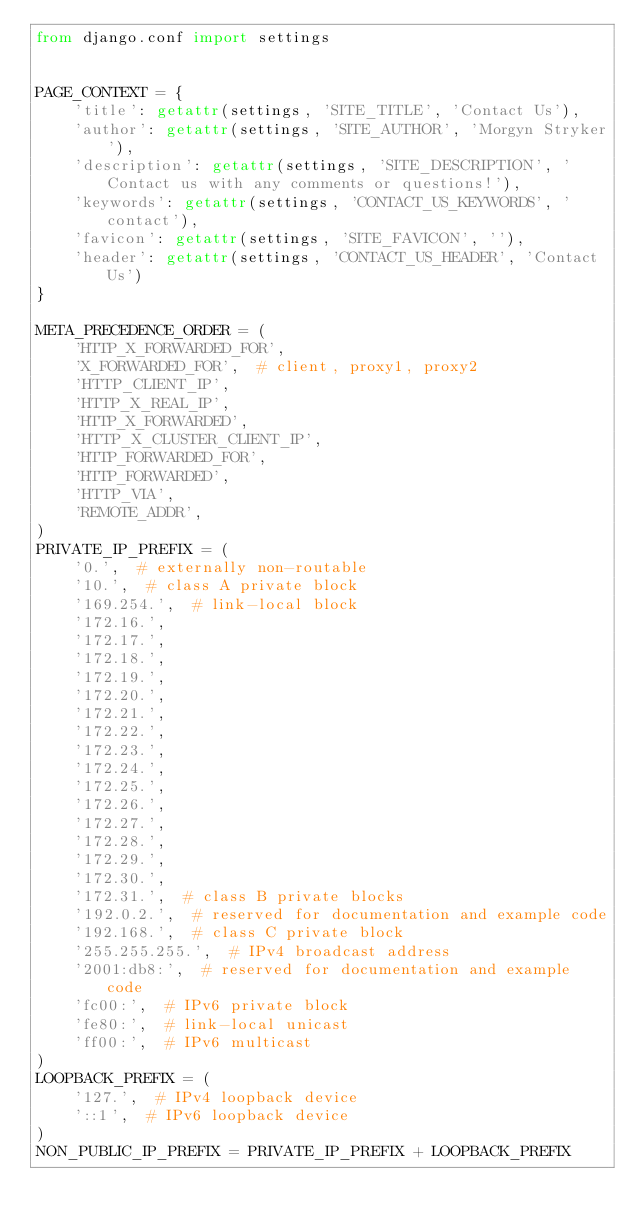Convert code to text. <code><loc_0><loc_0><loc_500><loc_500><_Python_>from django.conf import settings


PAGE_CONTEXT = {
    'title': getattr(settings, 'SITE_TITLE', 'Contact Us'),
    'author': getattr(settings, 'SITE_AUTHOR', 'Morgyn Stryker'),
    'description': getattr(settings, 'SITE_DESCRIPTION', 'Contact us with any comments or questions!'),
    'keywords': getattr(settings, 'CONTACT_US_KEYWORDS', 'contact'),
    'favicon': getattr(settings, 'SITE_FAVICON', ''),
    'header': getattr(settings, 'CONTACT_US_HEADER', 'Contact Us')
}

META_PRECEDENCE_ORDER = (
    'HTTP_X_FORWARDED_FOR',
    'X_FORWARDED_FOR',  # client, proxy1, proxy2
    'HTTP_CLIENT_IP',
    'HTTP_X_REAL_IP',
    'HTTP_X_FORWARDED',
    'HTTP_X_CLUSTER_CLIENT_IP',
    'HTTP_FORWARDED_FOR',
    'HTTP_FORWARDED',
    'HTTP_VIA',
    'REMOTE_ADDR',
)
PRIVATE_IP_PREFIX = (
    '0.',  # externally non-routable
    '10.',  # class A private block
    '169.254.',  # link-local block
    '172.16.',
    '172.17.',
    '172.18.',
    '172.19.',
    '172.20.',
    '172.21.',
    '172.22.',
    '172.23.',
    '172.24.',
    '172.25.',
    '172.26.',
    '172.27.',
    '172.28.',
    '172.29.',
    '172.30.',
    '172.31.',  # class B private blocks
    '192.0.2.',  # reserved for documentation and example code
    '192.168.',  # class C private block
    '255.255.255.',  # IPv4 broadcast address
    '2001:db8:',  # reserved for documentation and example code
    'fc00:',  # IPv6 private block
    'fe80:',  # link-local unicast
    'ff00:',  # IPv6 multicast
)
LOOPBACK_PREFIX = (
    '127.',  # IPv4 loopback device
    '::1',  # IPv6 loopback device
)
NON_PUBLIC_IP_PREFIX = PRIVATE_IP_PREFIX + LOOPBACK_PREFIX
</code> 